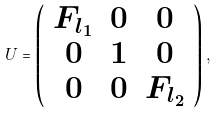<formula> <loc_0><loc_0><loc_500><loc_500>U = \left ( \begin{array} { c c c } F _ { l _ { 1 } } & 0 & 0 \\ 0 & 1 & 0 \\ 0 & 0 & F _ { l _ { 2 } } \end{array} \right ) ,</formula> 